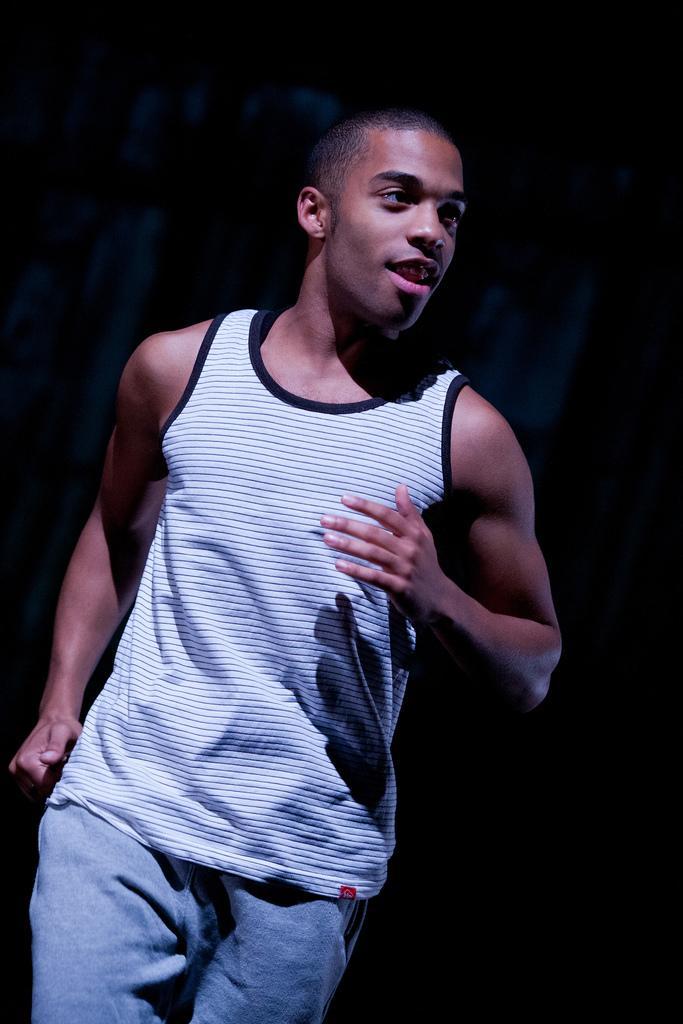How would you summarize this image in a sentence or two? In this image we can see person standing on the ground. 